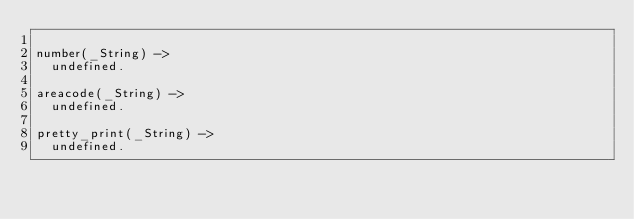<code> <loc_0><loc_0><loc_500><loc_500><_Erlang_>
number(_String) ->
  undefined.

areacode(_String) ->
  undefined.

pretty_print(_String) ->
  undefined.
</code> 